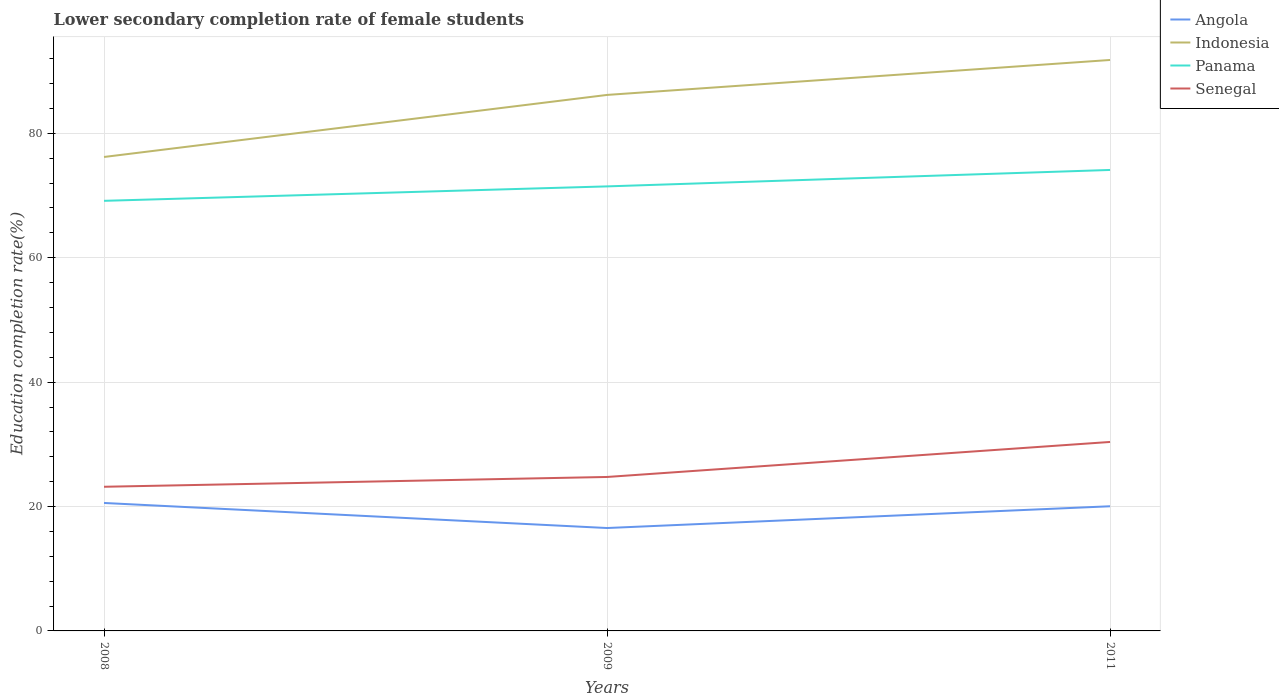Does the line corresponding to Angola intersect with the line corresponding to Panama?
Your answer should be very brief. No. Across all years, what is the maximum lower secondary completion rate of female students in Indonesia?
Your answer should be compact. 76.2. In which year was the lower secondary completion rate of female students in Senegal maximum?
Your answer should be very brief. 2008. What is the total lower secondary completion rate of female students in Indonesia in the graph?
Ensure brevity in your answer.  -5.62. What is the difference between the highest and the second highest lower secondary completion rate of female students in Senegal?
Keep it short and to the point. 7.21. Is the lower secondary completion rate of female students in Indonesia strictly greater than the lower secondary completion rate of female students in Senegal over the years?
Offer a terse response. No. How many years are there in the graph?
Your response must be concise. 3. What is the difference between two consecutive major ticks on the Y-axis?
Keep it short and to the point. 20. How many legend labels are there?
Ensure brevity in your answer.  4. How are the legend labels stacked?
Offer a terse response. Vertical. What is the title of the graph?
Your response must be concise. Lower secondary completion rate of female students. Does "Ireland" appear as one of the legend labels in the graph?
Provide a succinct answer. No. What is the label or title of the X-axis?
Give a very brief answer. Years. What is the label or title of the Y-axis?
Offer a terse response. Education completion rate(%). What is the Education completion rate(%) in Angola in 2008?
Your response must be concise. 20.57. What is the Education completion rate(%) in Indonesia in 2008?
Your response must be concise. 76.2. What is the Education completion rate(%) of Panama in 2008?
Offer a very short reply. 69.15. What is the Education completion rate(%) in Senegal in 2008?
Your answer should be very brief. 23.18. What is the Education completion rate(%) in Angola in 2009?
Your answer should be very brief. 16.54. What is the Education completion rate(%) in Indonesia in 2009?
Your response must be concise. 86.17. What is the Education completion rate(%) of Panama in 2009?
Your answer should be very brief. 71.47. What is the Education completion rate(%) in Senegal in 2009?
Provide a short and direct response. 24.75. What is the Education completion rate(%) in Angola in 2011?
Keep it short and to the point. 20.04. What is the Education completion rate(%) in Indonesia in 2011?
Provide a short and direct response. 91.79. What is the Education completion rate(%) in Panama in 2011?
Your response must be concise. 74.11. What is the Education completion rate(%) of Senegal in 2011?
Your answer should be very brief. 30.38. Across all years, what is the maximum Education completion rate(%) of Angola?
Provide a short and direct response. 20.57. Across all years, what is the maximum Education completion rate(%) in Indonesia?
Keep it short and to the point. 91.79. Across all years, what is the maximum Education completion rate(%) in Panama?
Provide a succinct answer. 74.11. Across all years, what is the maximum Education completion rate(%) of Senegal?
Your answer should be very brief. 30.38. Across all years, what is the minimum Education completion rate(%) in Angola?
Offer a very short reply. 16.54. Across all years, what is the minimum Education completion rate(%) in Indonesia?
Provide a succinct answer. 76.2. Across all years, what is the minimum Education completion rate(%) in Panama?
Your answer should be compact. 69.15. Across all years, what is the minimum Education completion rate(%) in Senegal?
Your response must be concise. 23.18. What is the total Education completion rate(%) in Angola in the graph?
Give a very brief answer. 57.16. What is the total Education completion rate(%) in Indonesia in the graph?
Your response must be concise. 254.16. What is the total Education completion rate(%) in Panama in the graph?
Offer a terse response. 214.73. What is the total Education completion rate(%) in Senegal in the graph?
Provide a short and direct response. 78.31. What is the difference between the Education completion rate(%) of Angola in 2008 and that in 2009?
Give a very brief answer. 4.03. What is the difference between the Education completion rate(%) in Indonesia in 2008 and that in 2009?
Provide a short and direct response. -9.98. What is the difference between the Education completion rate(%) of Panama in 2008 and that in 2009?
Your response must be concise. -2.32. What is the difference between the Education completion rate(%) in Senegal in 2008 and that in 2009?
Provide a short and direct response. -1.57. What is the difference between the Education completion rate(%) of Angola in 2008 and that in 2011?
Offer a very short reply. 0.53. What is the difference between the Education completion rate(%) in Indonesia in 2008 and that in 2011?
Offer a terse response. -15.6. What is the difference between the Education completion rate(%) in Panama in 2008 and that in 2011?
Ensure brevity in your answer.  -4.96. What is the difference between the Education completion rate(%) in Senegal in 2008 and that in 2011?
Your answer should be very brief. -7.21. What is the difference between the Education completion rate(%) in Angola in 2009 and that in 2011?
Keep it short and to the point. -3.5. What is the difference between the Education completion rate(%) of Indonesia in 2009 and that in 2011?
Provide a short and direct response. -5.62. What is the difference between the Education completion rate(%) of Panama in 2009 and that in 2011?
Make the answer very short. -2.64. What is the difference between the Education completion rate(%) of Senegal in 2009 and that in 2011?
Ensure brevity in your answer.  -5.63. What is the difference between the Education completion rate(%) in Angola in 2008 and the Education completion rate(%) in Indonesia in 2009?
Provide a short and direct response. -65.6. What is the difference between the Education completion rate(%) of Angola in 2008 and the Education completion rate(%) of Panama in 2009?
Offer a very short reply. -50.9. What is the difference between the Education completion rate(%) in Angola in 2008 and the Education completion rate(%) in Senegal in 2009?
Offer a terse response. -4.18. What is the difference between the Education completion rate(%) of Indonesia in 2008 and the Education completion rate(%) of Panama in 2009?
Give a very brief answer. 4.73. What is the difference between the Education completion rate(%) of Indonesia in 2008 and the Education completion rate(%) of Senegal in 2009?
Offer a terse response. 51.45. What is the difference between the Education completion rate(%) in Panama in 2008 and the Education completion rate(%) in Senegal in 2009?
Provide a succinct answer. 44.4. What is the difference between the Education completion rate(%) of Angola in 2008 and the Education completion rate(%) of Indonesia in 2011?
Your answer should be compact. -71.22. What is the difference between the Education completion rate(%) of Angola in 2008 and the Education completion rate(%) of Panama in 2011?
Give a very brief answer. -53.54. What is the difference between the Education completion rate(%) in Angola in 2008 and the Education completion rate(%) in Senegal in 2011?
Offer a terse response. -9.81. What is the difference between the Education completion rate(%) in Indonesia in 2008 and the Education completion rate(%) in Panama in 2011?
Offer a terse response. 2.09. What is the difference between the Education completion rate(%) in Indonesia in 2008 and the Education completion rate(%) in Senegal in 2011?
Ensure brevity in your answer.  45.82. What is the difference between the Education completion rate(%) of Panama in 2008 and the Education completion rate(%) of Senegal in 2011?
Ensure brevity in your answer.  38.77. What is the difference between the Education completion rate(%) of Angola in 2009 and the Education completion rate(%) of Indonesia in 2011?
Provide a succinct answer. -75.25. What is the difference between the Education completion rate(%) of Angola in 2009 and the Education completion rate(%) of Panama in 2011?
Ensure brevity in your answer.  -57.57. What is the difference between the Education completion rate(%) of Angola in 2009 and the Education completion rate(%) of Senegal in 2011?
Ensure brevity in your answer.  -13.84. What is the difference between the Education completion rate(%) of Indonesia in 2009 and the Education completion rate(%) of Panama in 2011?
Keep it short and to the point. 12.06. What is the difference between the Education completion rate(%) of Indonesia in 2009 and the Education completion rate(%) of Senegal in 2011?
Make the answer very short. 55.79. What is the difference between the Education completion rate(%) of Panama in 2009 and the Education completion rate(%) of Senegal in 2011?
Your answer should be compact. 41.09. What is the average Education completion rate(%) in Angola per year?
Provide a succinct answer. 19.05. What is the average Education completion rate(%) of Indonesia per year?
Provide a succinct answer. 84.72. What is the average Education completion rate(%) of Panama per year?
Give a very brief answer. 71.58. What is the average Education completion rate(%) of Senegal per year?
Your response must be concise. 26.1. In the year 2008, what is the difference between the Education completion rate(%) in Angola and Education completion rate(%) in Indonesia?
Make the answer very short. -55.63. In the year 2008, what is the difference between the Education completion rate(%) in Angola and Education completion rate(%) in Panama?
Offer a terse response. -48.58. In the year 2008, what is the difference between the Education completion rate(%) in Angola and Education completion rate(%) in Senegal?
Ensure brevity in your answer.  -2.6. In the year 2008, what is the difference between the Education completion rate(%) of Indonesia and Education completion rate(%) of Panama?
Keep it short and to the point. 7.05. In the year 2008, what is the difference between the Education completion rate(%) of Indonesia and Education completion rate(%) of Senegal?
Your response must be concise. 53.02. In the year 2008, what is the difference between the Education completion rate(%) of Panama and Education completion rate(%) of Senegal?
Provide a short and direct response. 45.97. In the year 2009, what is the difference between the Education completion rate(%) in Angola and Education completion rate(%) in Indonesia?
Your answer should be compact. -69.63. In the year 2009, what is the difference between the Education completion rate(%) in Angola and Education completion rate(%) in Panama?
Your answer should be very brief. -54.93. In the year 2009, what is the difference between the Education completion rate(%) in Angola and Education completion rate(%) in Senegal?
Offer a very short reply. -8.21. In the year 2009, what is the difference between the Education completion rate(%) in Indonesia and Education completion rate(%) in Panama?
Your answer should be compact. 14.7. In the year 2009, what is the difference between the Education completion rate(%) of Indonesia and Education completion rate(%) of Senegal?
Provide a succinct answer. 61.42. In the year 2009, what is the difference between the Education completion rate(%) in Panama and Education completion rate(%) in Senegal?
Ensure brevity in your answer.  46.72. In the year 2011, what is the difference between the Education completion rate(%) of Angola and Education completion rate(%) of Indonesia?
Offer a very short reply. -71.75. In the year 2011, what is the difference between the Education completion rate(%) of Angola and Education completion rate(%) of Panama?
Provide a short and direct response. -54.07. In the year 2011, what is the difference between the Education completion rate(%) of Angola and Education completion rate(%) of Senegal?
Provide a short and direct response. -10.34. In the year 2011, what is the difference between the Education completion rate(%) of Indonesia and Education completion rate(%) of Panama?
Keep it short and to the point. 17.68. In the year 2011, what is the difference between the Education completion rate(%) in Indonesia and Education completion rate(%) in Senegal?
Keep it short and to the point. 61.41. In the year 2011, what is the difference between the Education completion rate(%) in Panama and Education completion rate(%) in Senegal?
Your answer should be compact. 43.73. What is the ratio of the Education completion rate(%) of Angola in 2008 to that in 2009?
Provide a succinct answer. 1.24. What is the ratio of the Education completion rate(%) of Indonesia in 2008 to that in 2009?
Keep it short and to the point. 0.88. What is the ratio of the Education completion rate(%) in Panama in 2008 to that in 2009?
Your answer should be compact. 0.97. What is the ratio of the Education completion rate(%) of Senegal in 2008 to that in 2009?
Your answer should be compact. 0.94. What is the ratio of the Education completion rate(%) in Angola in 2008 to that in 2011?
Your answer should be compact. 1.03. What is the ratio of the Education completion rate(%) of Indonesia in 2008 to that in 2011?
Your response must be concise. 0.83. What is the ratio of the Education completion rate(%) in Panama in 2008 to that in 2011?
Offer a terse response. 0.93. What is the ratio of the Education completion rate(%) in Senegal in 2008 to that in 2011?
Make the answer very short. 0.76. What is the ratio of the Education completion rate(%) in Angola in 2009 to that in 2011?
Your response must be concise. 0.83. What is the ratio of the Education completion rate(%) in Indonesia in 2009 to that in 2011?
Offer a very short reply. 0.94. What is the ratio of the Education completion rate(%) of Panama in 2009 to that in 2011?
Your answer should be compact. 0.96. What is the ratio of the Education completion rate(%) in Senegal in 2009 to that in 2011?
Ensure brevity in your answer.  0.81. What is the difference between the highest and the second highest Education completion rate(%) of Angola?
Keep it short and to the point. 0.53. What is the difference between the highest and the second highest Education completion rate(%) in Indonesia?
Ensure brevity in your answer.  5.62. What is the difference between the highest and the second highest Education completion rate(%) in Panama?
Offer a terse response. 2.64. What is the difference between the highest and the second highest Education completion rate(%) of Senegal?
Your answer should be very brief. 5.63. What is the difference between the highest and the lowest Education completion rate(%) of Angola?
Your response must be concise. 4.03. What is the difference between the highest and the lowest Education completion rate(%) in Indonesia?
Provide a short and direct response. 15.6. What is the difference between the highest and the lowest Education completion rate(%) of Panama?
Your answer should be very brief. 4.96. What is the difference between the highest and the lowest Education completion rate(%) of Senegal?
Keep it short and to the point. 7.21. 